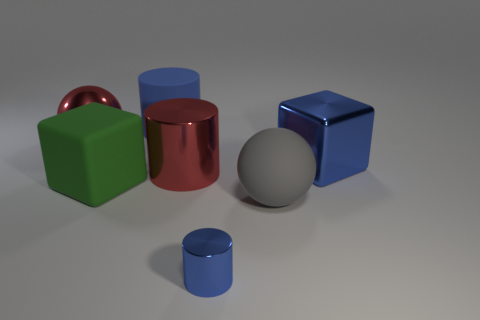Subtract all gray spheres. How many blue cylinders are left? 2 Subtract all large red cylinders. How many cylinders are left? 2 Add 3 green matte cubes. How many objects exist? 10 Subtract all red cylinders. How many cylinders are left? 2 Subtract all cubes. How many objects are left? 5 Subtract all red cylinders. Subtract all brown cubes. How many cylinders are left? 2 Subtract all tiny red objects. Subtract all blue cylinders. How many objects are left? 5 Add 4 large metallic spheres. How many large metallic spheres are left? 5 Add 2 small yellow rubber blocks. How many small yellow rubber blocks exist? 2 Subtract 1 gray spheres. How many objects are left? 6 